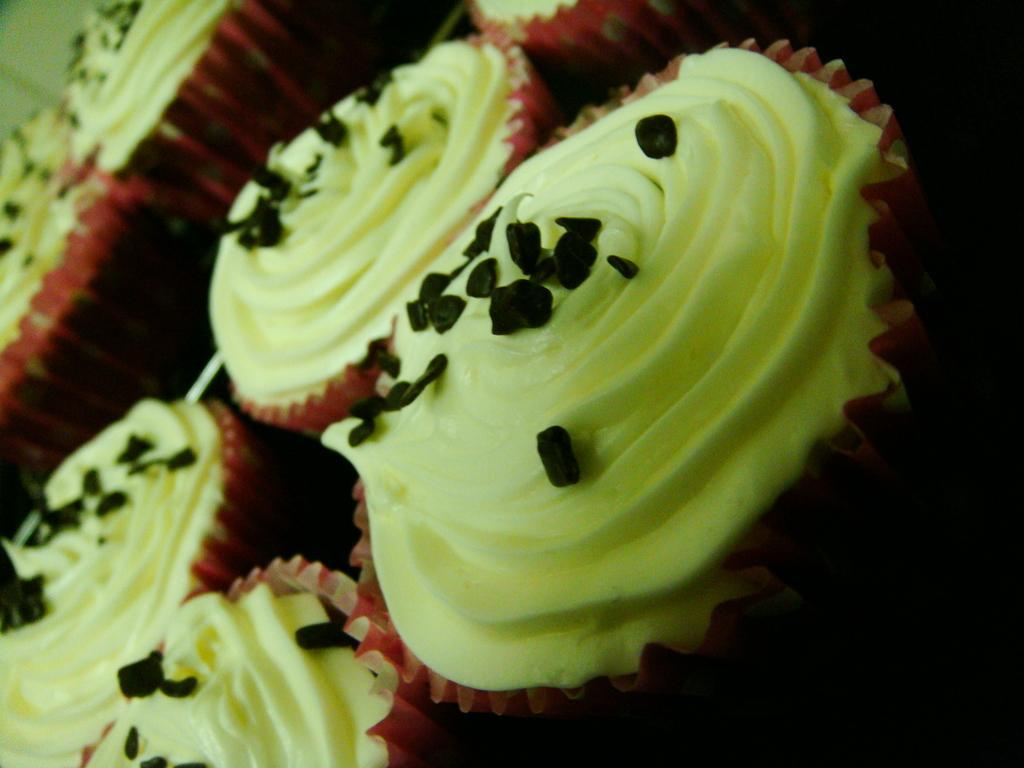What type of dessert can be seen in the image? There are cupcakes in the image. What specific ingredient is visible on the cupcakes? There are chocolate chips on the cake. How many cherries are on top of the cupcakes in the image? There are no cherries visible on the cupcakes in the image. What type of vegetation can be seen growing around the cupcakes in the image? There is no vegetation present in the image; it only features cupcakes with chocolate chips. 